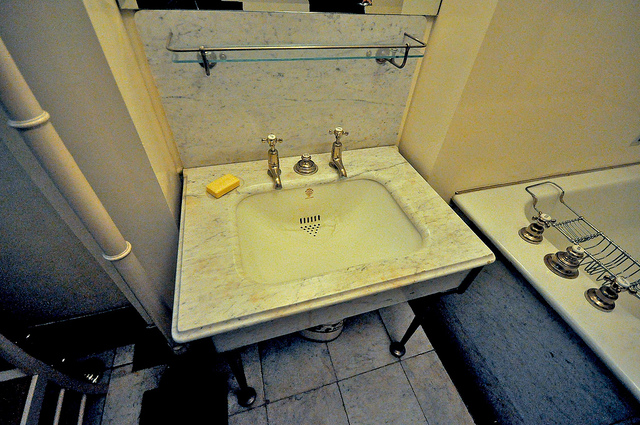If the bathroom was in an exotic location, describe an exotic scenario in this bathroom. Imagine this bathroom in a luxurious resort on a tropical island. Through a large, open window, a gentle ocean breeze carries the scent of saltwater and tropical flowers into the room. The soothing sound of waves crashing against the shore creates a calming ambiance. Palm leaves rustle outside, and the golden hues of a setting sun cast a warm, orange glow over the marble surfaces.
The marble countertop is adorned with exotic shells and vibrant flowers picked from the island's lush gardens. An intricately designed wooden screen offers a blend of privacy and artistry, casting delicate shadows that dance across the room. The air is humid but pleasant, and the sound of distant bird calls adds to the serene atmosphere.
A couple, sun-kissed from a day of beach adventures, enters the bathroom. They share a laugh as they wash off the sand and sea, the water droplets glistening on their skin. The space, elegant yet infused with the essence of the tropics, offers the perfect retreat to unwind and connect with nature, creating unforgettable memories in a setting of unparalleled beauty. What if this bathroom was historical, belonging to someone famous? How would it look then? If this bathroom belonged to someone famous in the past, such as a renowned author or a celebrated artist, it would reflect their unique personality and style. The marble countertop might hold a vintage perfume bottle and a silver brush set, each with intricate engravings. The fixtures might be more ornate, with brass or gold finishes that give a sense of opulence and grandeur.
The walls could be adorned with framed handwritten notes or sketches, offering a glimpse into their creative process. Perhaps a beautiful antique mirror hangs above the sink, its edges decorated with delicate, artisanal designs. A plush, intricately patterned rug might rest on the floor, contrasting with the cool elegance of the marble.
The room would likely have a subtle yet distinct fragrance, the kind associated with a bygone era. Items like a porcelain washbasin or a vintage oil lamp would add an authentic historical touch, capturing the spirit and sophistication of its famous owner. This bathroom would be more than just a functional space—it would be a testament to a life of creativity and legacy, rich with stories waiting to be discovered. 